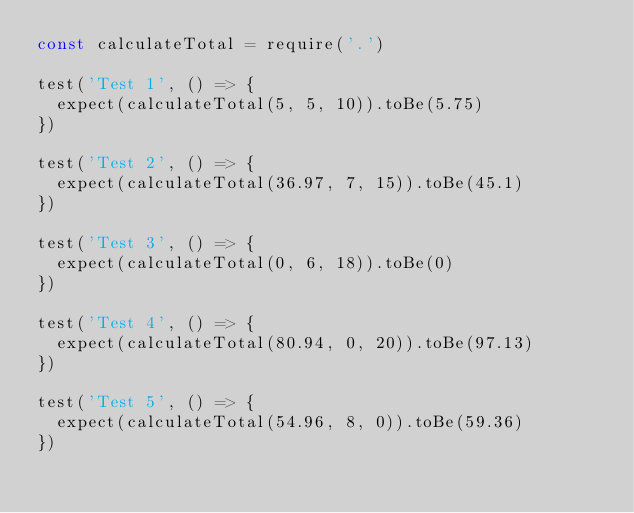<code> <loc_0><loc_0><loc_500><loc_500><_JavaScript_>const calculateTotal = require('.')

test('Test 1', () => {
  expect(calculateTotal(5, 5, 10)).toBe(5.75)
})

test('Test 2', () => {
  expect(calculateTotal(36.97, 7, 15)).toBe(45.1)
})

test('Test 3', () => {
  expect(calculateTotal(0, 6, 18)).toBe(0)
})

test('Test 4', () => {
  expect(calculateTotal(80.94, 0, 20)).toBe(97.13)
})

test('Test 5', () => {
  expect(calculateTotal(54.96, 8, 0)).toBe(59.36)
})
</code> 